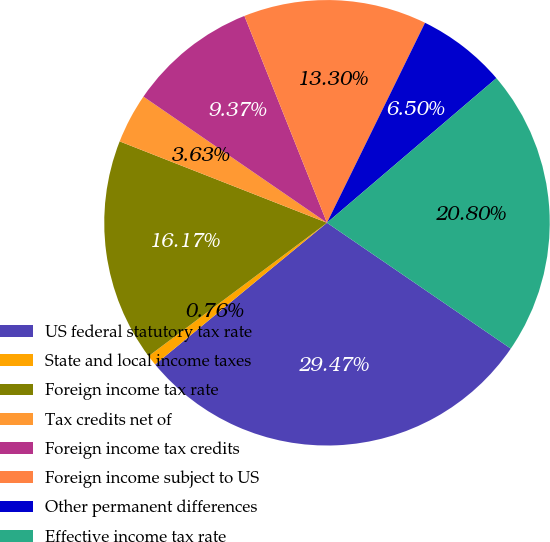Convert chart. <chart><loc_0><loc_0><loc_500><loc_500><pie_chart><fcel>US federal statutory tax rate<fcel>State and local income taxes<fcel>Foreign income tax rate<fcel>Tax credits net of<fcel>Foreign income tax credits<fcel>Foreign income subject to US<fcel>Other permanent differences<fcel>Effective income tax rate<nl><fcel>29.47%<fcel>0.76%<fcel>16.17%<fcel>3.63%<fcel>9.37%<fcel>13.3%<fcel>6.5%<fcel>20.8%<nl></chart> 